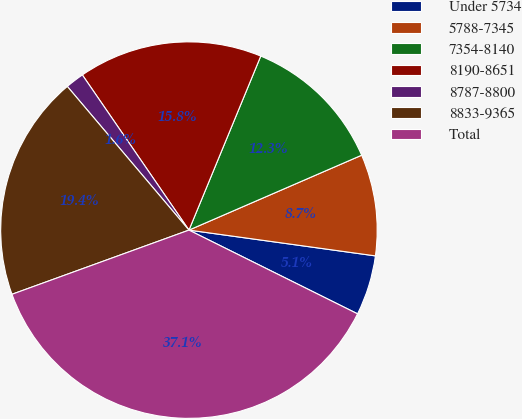<chart> <loc_0><loc_0><loc_500><loc_500><pie_chart><fcel>Under 5734<fcel>5788-7345<fcel>7354-8140<fcel>8190-8651<fcel>8787-8800<fcel>8833-9365<fcel>Total<nl><fcel>5.15%<fcel>8.7%<fcel>12.26%<fcel>15.81%<fcel>1.6%<fcel>19.36%<fcel>37.13%<nl></chart> 